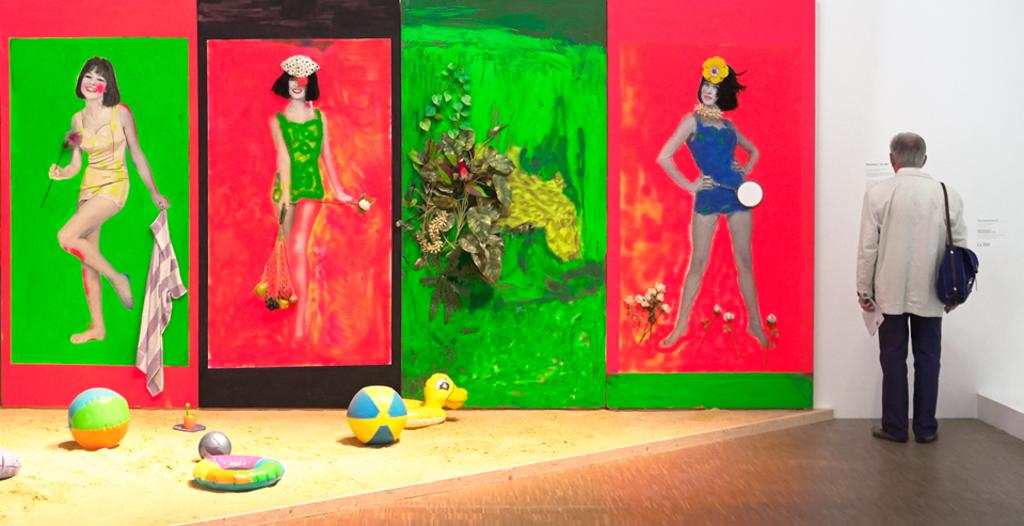What is the main subject of the image? There is a man in the image. What is the man doing in the image? The man is standing in the image. What is the man holding in the image? The man is holding a paper and carrying a bag in the image. What can be seen on the left side of the image? There are paintings on the left side of the image. What other objects are present in the image? There are dolls in the image. What is the background of the image? There is a wall in the image. What type of guitar can be seen in the image? There is no guitar present in the image. How does the wind affect the man in the image? There is no wind present in the image, and therefore it does not affect the man. 